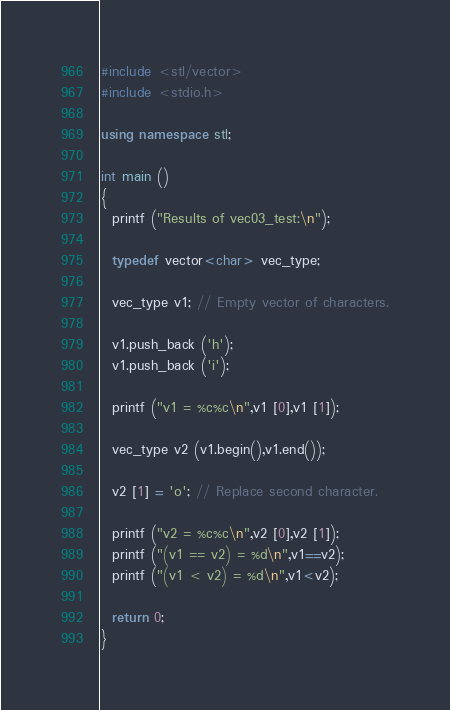Convert code to text. <code><loc_0><loc_0><loc_500><loc_500><_C++_>#include <stl/vector>
#include <stdio.h>

using namespace stl;

int main ()
{
  printf ("Results of vec03_test:\n");
  
  typedef vector<char> vec_type;

  vec_type v1; // Empty vector of characters.
  
  v1.push_back ('h');
  v1.push_back ('i');
  
  printf ("v1 = %c%c\n",v1 [0],v1 [1]);

  vec_type v2 (v1.begin(),v1.end());
  
  v2 [1] = 'o'; // Replace second character.
  
  printf ("v2 = %c%c\n",v2 [0],v2 [1]);
  printf ("(v1 == v2) = %d\n",v1==v2);
  printf ("(v1 < v2) = %d\n",v1<v2);  

  return 0;
}
</code> 